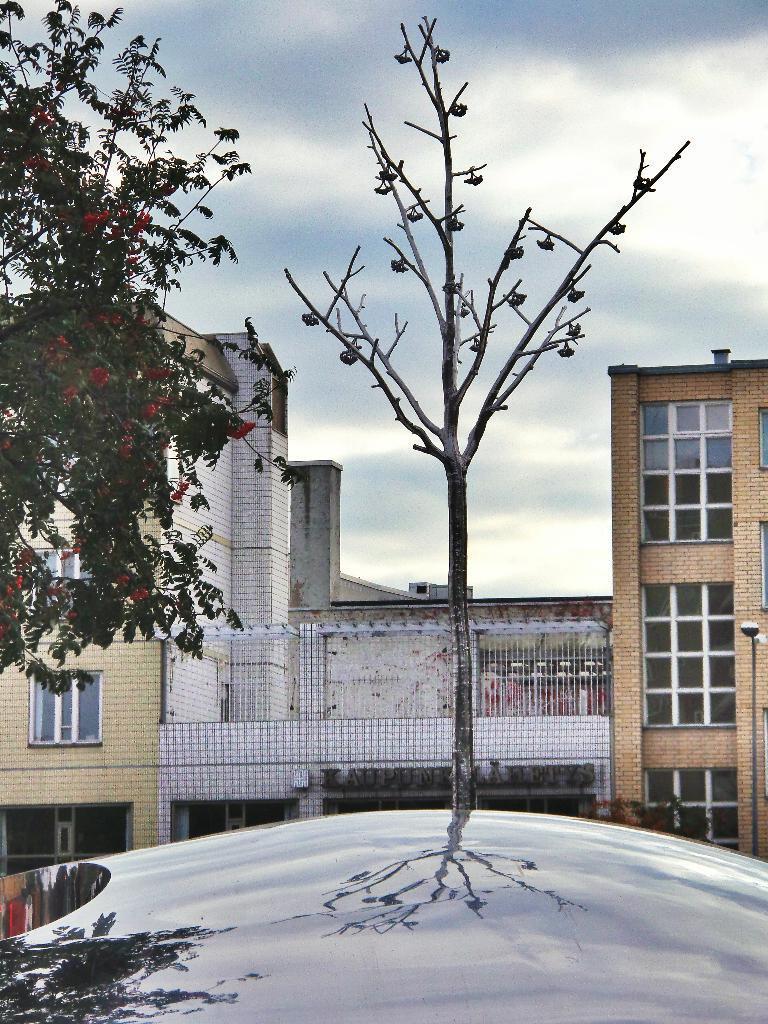Can you describe this image briefly? In this image in front there are trees. In the background of the image there are buildings and sky. At the bottom of the image we can see the reflection of the trees. 